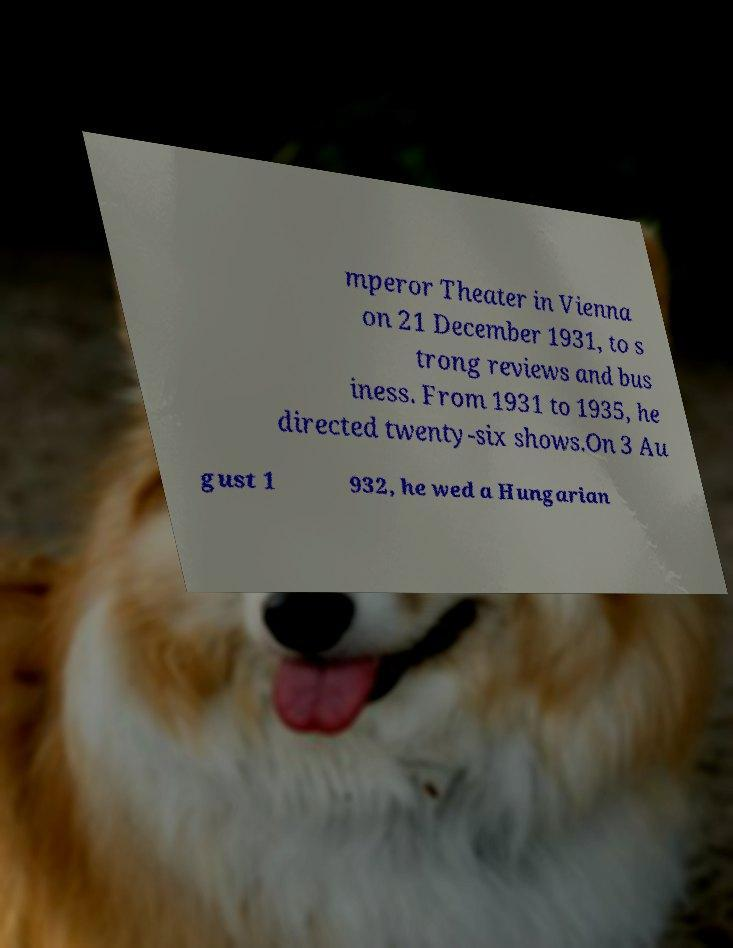Please read and relay the text visible in this image. What does it say? mperor Theater in Vienna on 21 December 1931, to s trong reviews and bus iness. From 1931 to 1935, he directed twenty-six shows.On 3 Au gust 1 932, he wed a Hungarian 